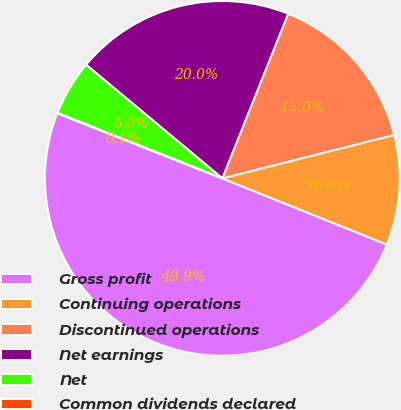<chart> <loc_0><loc_0><loc_500><loc_500><pie_chart><fcel>Gross profit<fcel>Continuing operations<fcel>Discontinued operations<fcel>Net earnings<fcel>Net<fcel>Common dividends declared<nl><fcel>49.89%<fcel>10.02%<fcel>15.01%<fcel>19.99%<fcel>5.04%<fcel>0.05%<nl></chart> 